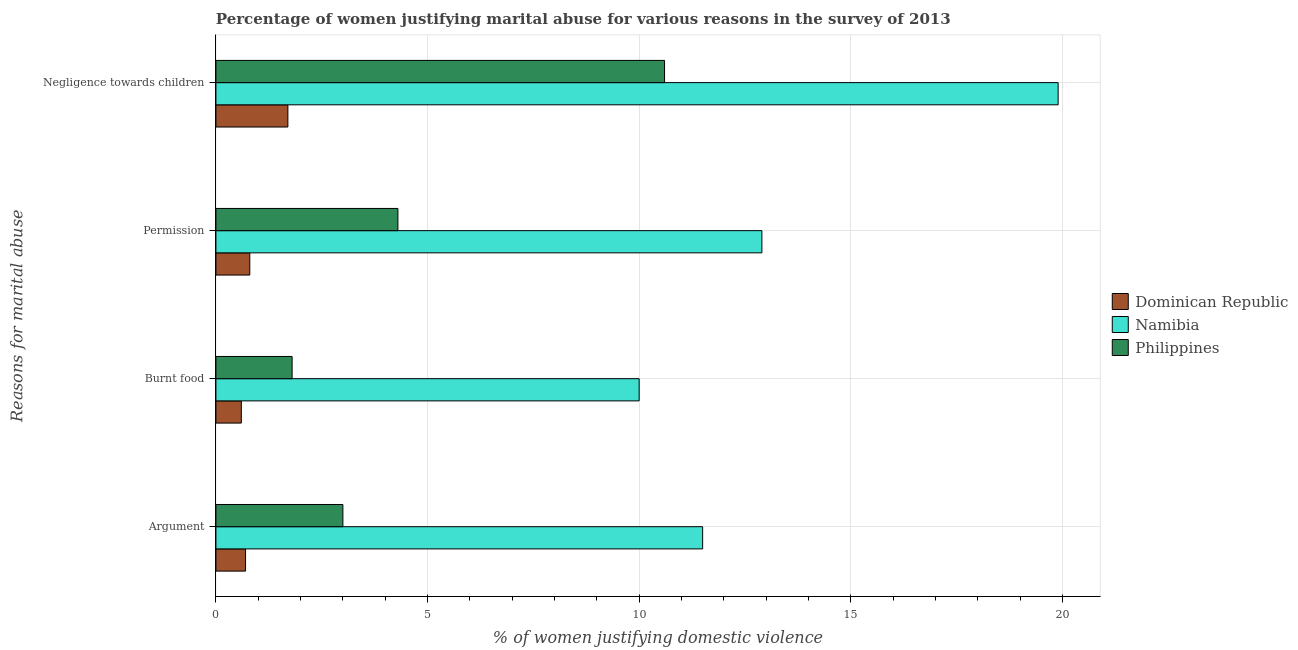How many different coloured bars are there?
Offer a very short reply. 3. Are the number of bars per tick equal to the number of legend labels?
Provide a succinct answer. Yes. How many bars are there on the 1st tick from the bottom?
Offer a very short reply. 3. What is the label of the 3rd group of bars from the top?
Offer a very short reply. Burnt food. What is the percentage of women justifying abuse for going without permission in Dominican Republic?
Keep it short and to the point. 0.8. Across all countries, what is the minimum percentage of women justifying abuse for burning food?
Keep it short and to the point. 0.6. In which country was the percentage of women justifying abuse in the case of an argument maximum?
Provide a short and direct response. Namibia. In which country was the percentage of women justifying abuse for burning food minimum?
Keep it short and to the point. Dominican Republic. What is the total percentage of women justifying abuse for showing negligence towards children in the graph?
Provide a succinct answer. 32.2. What is the average percentage of women justifying abuse for going without permission per country?
Your answer should be very brief. 6. What is the difference between the percentage of women justifying abuse for going without permission and percentage of women justifying abuse for burning food in Dominican Republic?
Your response must be concise. 0.2. What is the ratio of the percentage of women justifying abuse for going without permission in Dominican Republic to that in Philippines?
Your answer should be very brief. 0.19. What is the difference between the highest and the second highest percentage of women justifying abuse for showing negligence towards children?
Your answer should be very brief. 9.3. What is the difference between the highest and the lowest percentage of women justifying abuse for showing negligence towards children?
Offer a very short reply. 18.2. Is the sum of the percentage of women justifying abuse for burning food in Namibia and Dominican Republic greater than the maximum percentage of women justifying abuse in the case of an argument across all countries?
Keep it short and to the point. No. Is it the case that in every country, the sum of the percentage of women justifying abuse in the case of an argument and percentage of women justifying abuse for going without permission is greater than the sum of percentage of women justifying abuse for burning food and percentage of women justifying abuse for showing negligence towards children?
Provide a succinct answer. No. What does the 2nd bar from the top in Argument represents?
Offer a terse response. Namibia. What does the 2nd bar from the bottom in Argument represents?
Your answer should be very brief. Namibia. Are all the bars in the graph horizontal?
Make the answer very short. Yes. What is the difference between two consecutive major ticks on the X-axis?
Keep it short and to the point. 5. Are the values on the major ticks of X-axis written in scientific E-notation?
Ensure brevity in your answer.  No. Does the graph contain grids?
Your response must be concise. Yes. How many legend labels are there?
Your answer should be very brief. 3. What is the title of the graph?
Keep it short and to the point. Percentage of women justifying marital abuse for various reasons in the survey of 2013. What is the label or title of the X-axis?
Your answer should be compact. % of women justifying domestic violence. What is the label or title of the Y-axis?
Ensure brevity in your answer.  Reasons for marital abuse. What is the % of women justifying domestic violence of Namibia in Argument?
Offer a very short reply. 11.5. What is the % of women justifying domestic violence of Namibia in Burnt food?
Ensure brevity in your answer.  10. What is the % of women justifying domestic violence in Philippines in Burnt food?
Provide a short and direct response. 1.8. What is the % of women justifying domestic violence of Dominican Republic in Permission?
Offer a terse response. 0.8. What is the % of women justifying domestic violence in Philippines in Permission?
Offer a very short reply. 4.3. What is the % of women justifying domestic violence of Philippines in Negligence towards children?
Your answer should be compact. 10.6. Across all Reasons for marital abuse, what is the maximum % of women justifying domestic violence in Dominican Republic?
Provide a succinct answer. 1.7. Across all Reasons for marital abuse, what is the maximum % of women justifying domestic violence of Philippines?
Provide a succinct answer. 10.6. What is the total % of women justifying domestic violence in Namibia in the graph?
Your response must be concise. 54.3. What is the total % of women justifying domestic violence in Philippines in the graph?
Make the answer very short. 19.7. What is the difference between the % of women justifying domestic violence of Dominican Republic in Argument and that in Burnt food?
Provide a succinct answer. 0.1. What is the difference between the % of women justifying domestic violence in Namibia in Argument and that in Burnt food?
Offer a terse response. 1.5. What is the difference between the % of women justifying domestic violence of Philippines in Argument and that in Burnt food?
Your response must be concise. 1.2. What is the difference between the % of women justifying domestic violence of Dominican Republic in Argument and that in Negligence towards children?
Offer a very short reply. -1. What is the difference between the % of women justifying domestic violence of Namibia in Burnt food and that in Permission?
Give a very brief answer. -2.9. What is the difference between the % of women justifying domestic violence of Philippines in Burnt food and that in Negligence towards children?
Make the answer very short. -8.8. What is the difference between the % of women justifying domestic violence in Namibia in Permission and that in Negligence towards children?
Offer a terse response. -7. What is the difference between the % of women justifying domestic violence in Dominican Republic in Argument and the % of women justifying domestic violence in Namibia in Burnt food?
Your response must be concise. -9.3. What is the difference between the % of women justifying domestic violence in Dominican Republic in Argument and the % of women justifying domestic violence in Philippines in Burnt food?
Offer a very short reply. -1.1. What is the difference between the % of women justifying domestic violence of Namibia in Argument and the % of women justifying domestic violence of Philippines in Burnt food?
Your response must be concise. 9.7. What is the difference between the % of women justifying domestic violence of Dominican Republic in Argument and the % of women justifying domestic violence of Namibia in Permission?
Give a very brief answer. -12.2. What is the difference between the % of women justifying domestic violence in Dominican Republic in Argument and the % of women justifying domestic violence in Namibia in Negligence towards children?
Your answer should be compact. -19.2. What is the difference between the % of women justifying domestic violence of Namibia in Argument and the % of women justifying domestic violence of Philippines in Negligence towards children?
Offer a terse response. 0.9. What is the difference between the % of women justifying domestic violence of Dominican Republic in Burnt food and the % of women justifying domestic violence of Namibia in Negligence towards children?
Your answer should be compact. -19.3. What is the difference between the % of women justifying domestic violence of Dominican Republic in Burnt food and the % of women justifying domestic violence of Philippines in Negligence towards children?
Ensure brevity in your answer.  -10. What is the difference between the % of women justifying domestic violence in Dominican Republic in Permission and the % of women justifying domestic violence in Namibia in Negligence towards children?
Ensure brevity in your answer.  -19.1. What is the difference between the % of women justifying domestic violence in Namibia in Permission and the % of women justifying domestic violence in Philippines in Negligence towards children?
Provide a succinct answer. 2.3. What is the average % of women justifying domestic violence in Dominican Republic per Reasons for marital abuse?
Offer a very short reply. 0.95. What is the average % of women justifying domestic violence of Namibia per Reasons for marital abuse?
Give a very brief answer. 13.57. What is the average % of women justifying domestic violence of Philippines per Reasons for marital abuse?
Make the answer very short. 4.92. What is the difference between the % of women justifying domestic violence of Dominican Republic and % of women justifying domestic violence of Namibia in Argument?
Provide a succinct answer. -10.8. What is the difference between the % of women justifying domestic violence of Dominican Republic and % of women justifying domestic violence of Namibia in Burnt food?
Your answer should be compact. -9.4. What is the difference between the % of women justifying domestic violence of Namibia and % of women justifying domestic violence of Philippines in Burnt food?
Keep it short and to the point. 8.2. What is the difference between the % of women justifying domestic violence in Dominican Republic and % of women justifying domestic violence in Philippines in Permission?
Your answer should be very brief. -3.5. What is the difference between the % of women justifying domestic violence in Namibia and % of women justifying domestic violence in Philippines in Permission?
Your response must be concise. 8.6. What is the difference between the % of women justifying domestic violence in Dominican Republic and % of women justifying domestic violence in Namibia in Negligence towards children?
Offer a very short reply. -18.2. What is the difference between the % of women justifying domestic violence of Dominican Republic and % of women justifying domestic violence of Philippines in Negligence towards children?
Offer a very short reply. -8.9. What is the difference between the % of women justifying domestic violence of Namibia and % of women justifying domestic violence of Philippines in Negligence towards children?
Make the answer very short. 9.3. What is the ratio of the % of women justifying domestic violence of Namibia in Argument to that in Burnt food?
Your answer should be compact. 1.15. What is the ratio of the % of women justifying domestic violence in Philippines in Argument to that in Burnt food?
Keep it short and to the point. 1.67. What is the ratio of the % of women justifying domestic violence in Namibia in Argument to that in Permission?
Your answer should be compact. 0.89. What is the ratio of the % of women justifying domestic violence in Philippines in Argument to that in Permission?
Your answer should be compact. 0.7. What is the ratio of the % of women justifying domestic violence in Dominican Republic in Argument to that in Negligence towards children?
Make the answer very short. 0.41. What is the ratio of the % of women justifying domestic violence in Namibia in Argument to that in Negligence towards children?
Offer a very short reply. 0.58. What is the ratio of the % of women justifying domestic violence of Philippines in Argument to that in Negligence towards children?
Provide a succinct answer. 0.28. What is the ratio of the % of women justifying domestic violence of Namibia in Burnt food to that in Permission?
Provide a succinct answer. 0.78. What is the ratio of the % of women justifying domestic violence in Philippines in Burnt food to that in Permission?
Your response must be concise. 0.42. What is the ratio of the % of women justifying domestic violence of Dominican Republic in Burnt food to that in Negligence towards children?
Ensure brevity in your answer.  0.35. What is the ratio of the % of women justifying domestic violence of Namibia in Burnt food to that in Negligence towards children?
Make the answer very short. 0.5. What is the ratio of the % of women justifying domestic violence of Philippines in Burnt food to that in Negligence towards children?
Keep it short and to the point. 0.17. What is the ratio of the % of women justifying domestic violence of Dominican Republic in Permission to that in Negligence towards children?
Keep it short and to the point. 0.47. What is the ratio of the % of women justifying domestic violence in Namibia in Permission to that in Negligence towards children?
Give a very brief answer. 0.65. What is the ratio of the % of women justifying domestic violence in Philippines in Permission to that in Negligence towards children?
Your answer should be compact. 0.41. What is the difference between the highest and the second highest % of women justifying domestic violence of Dominican Republic?
Offer a terse response. 0.9. What is the difference between the highest and the second highest % of women justifying domestic violence in Philippines?
Offer a terse response. 6.3. What is the difference between the highest and the lowest % of women justifying domestic violence in Dominican Republic?
Provide a succinct answer. 1.1. 